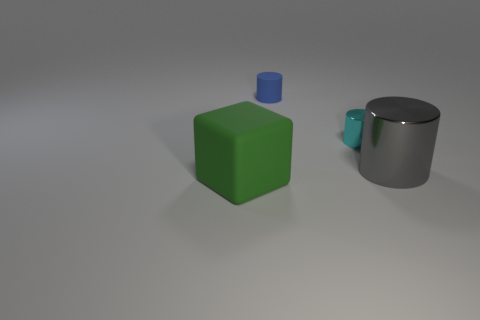Is there a big shiny thing of the same shape as the tiny cyan object?
Your answer should be very brief. Yes. How many objects are small blue rubber blocks or green things that are to the left of the small cyan shiny thing?
Ensure brevity in your answer.  1. What number of other things are there of the same material as the cube
Make the answer very short. 1. How many objects are either big red shiny things or cylinders?
Give a very brief answer. 3. Is the number of green objects that are right of the block greater than the number of blue rubber cylinders that are left of the tiny matte thing?
Keep it short and to the point. No. There is a metal cylinder that is to the left of the big object right of the large object that is to the left of the cyan cylinder; what is its size?
Give a very brief answer. Small. What color is the tiny rubber object that is the same shape as the cyan shiny thing?
Your response must be concise. Blue. Is the number of things on the left side of the matte cylinder greater than the number of large purple matte spheres?
Make the answer very short. Yes. There is a big gray metal object; does it have the same shape as the metal object that is behind the gray shiny object?
Provide a succinct answer. Yes. There is a gray thing that is the same shape as the cyan shiny thing; what is its size?
Give a very brief answer. Large. 